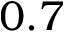Convert formula to latex. <formula><loc_0><loc_0><loc_500><loc_500>0 . 7</formula> 